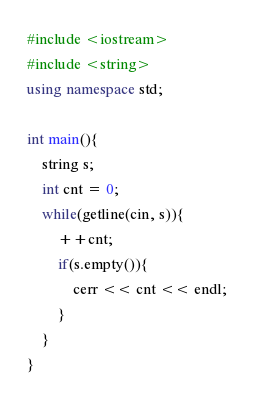<code> <loc_0><loc_0><loc_500><loc_500><_C++_>#include <iostream>
#include <string>
using namespace std;

int main(){
	string s;
	int cnt = 0;
	while(getline(cin, s)){
		++cnt;
		if(s.empty()){
			cerr << cnt << endl;
		}
	}
}</code> 